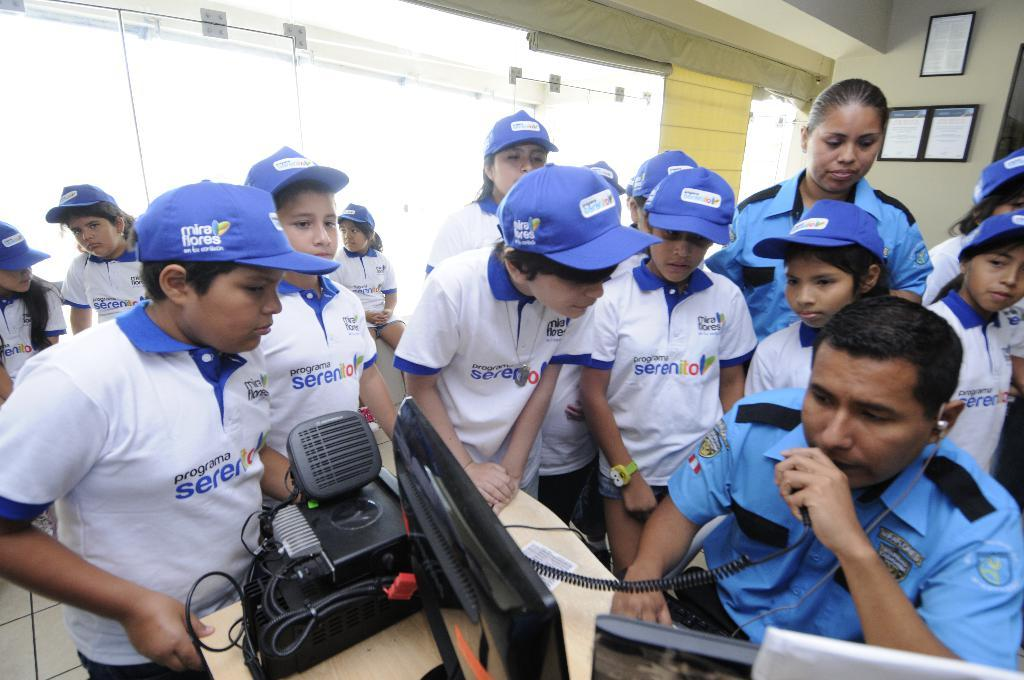<image>
Summarize the visual content of the image. Kids wear hats that have the words mira flores on them. 